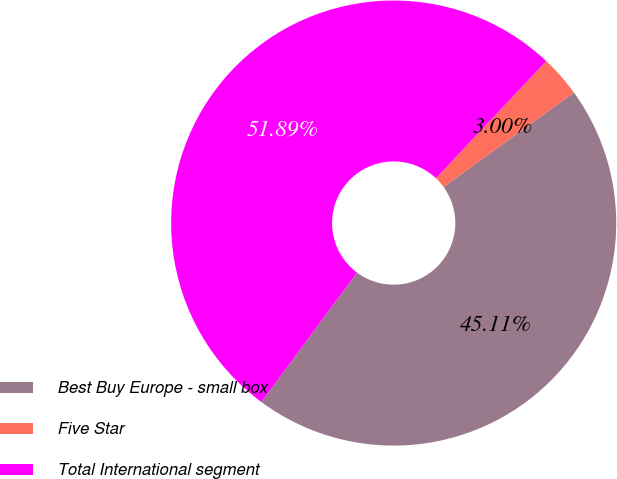<chart> <loc_0><loc_0><loc_500><loc_500><pie_chart><fcel>Best Buy Europe - small box<fcel>Five Star<fcel>Total International segment<nl><fcel>45.11%<fcel>3.0%<fcel>51.89%<nl></chart> 